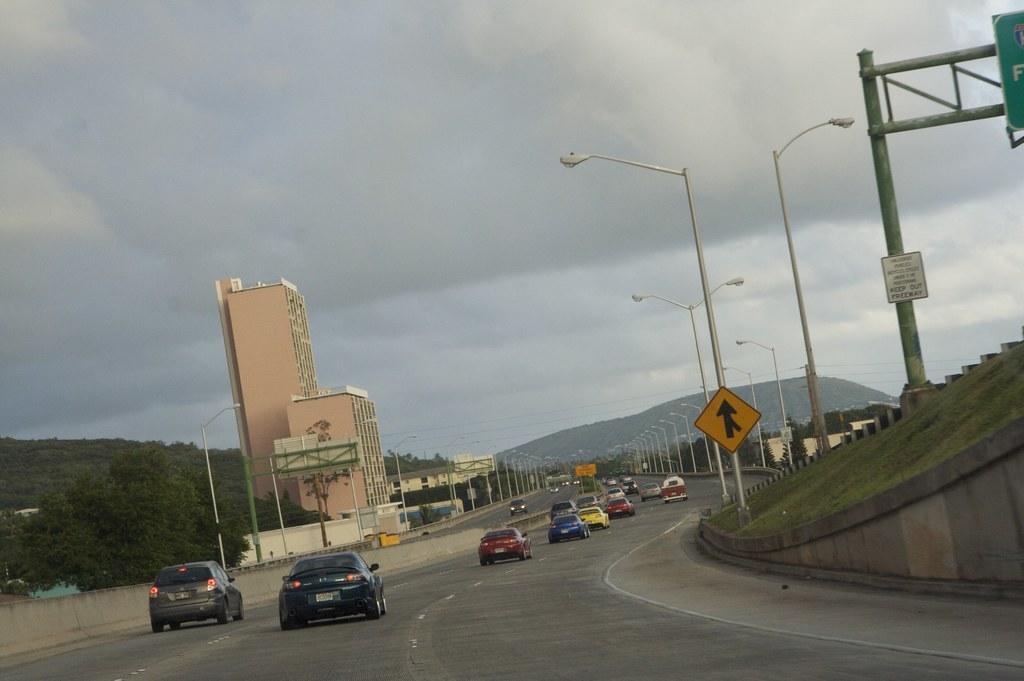Describe this image in one or two sentences. In this picture we can see vehicles on the road and there is a hill. On the left and right side of the roads, there are street lights. On the right side of the image, there are poles with boards and there is grass. On the left side of the image, there are buildings and trees. At the top of the image, there is the cloudy sky. 